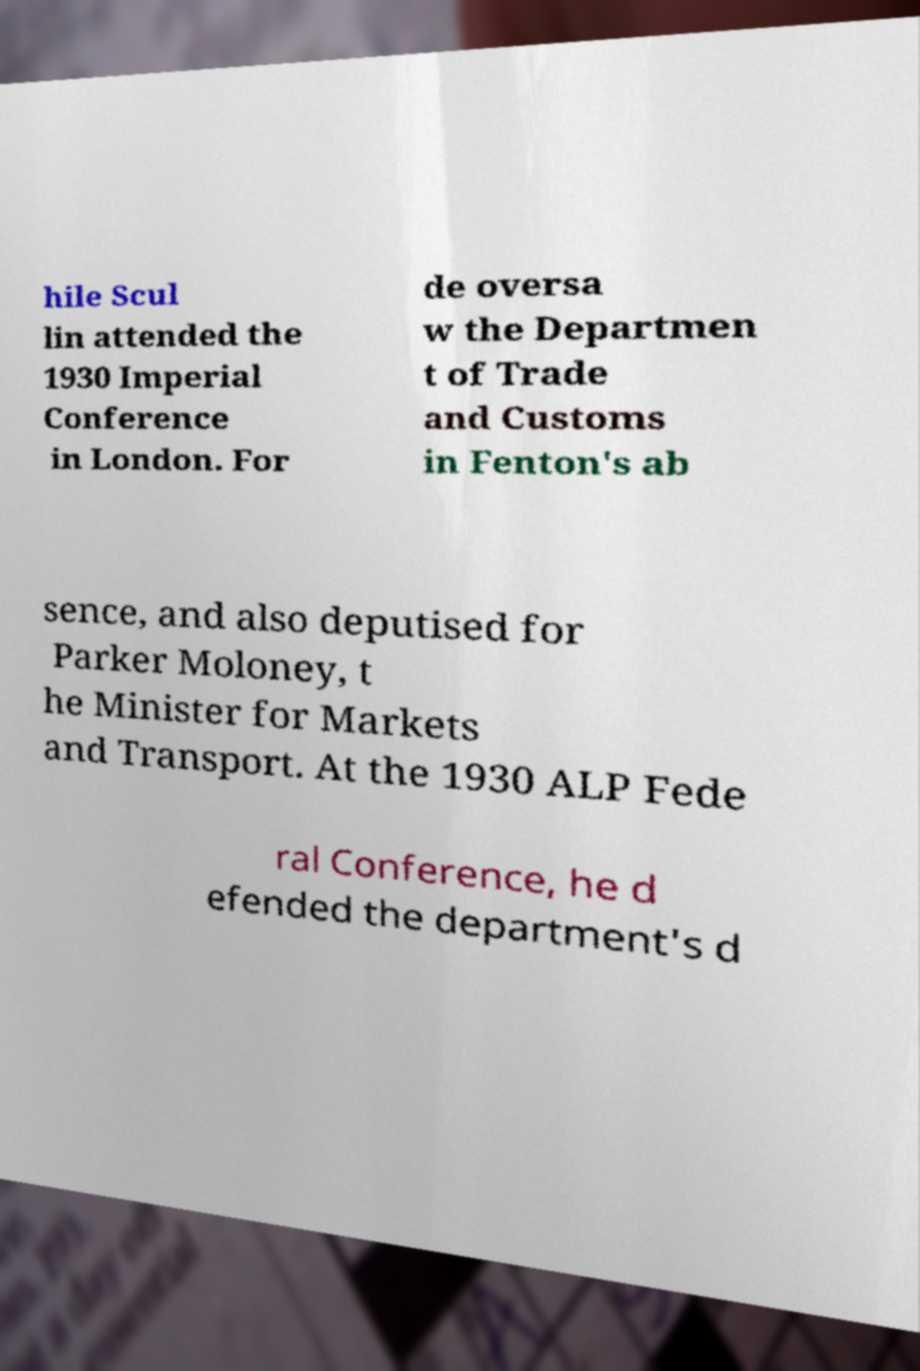Could you assist in decoding the text presented in this image and type it out clearly? hile Scul lin attended the 1930 Imperial Conference in London. For de oversa w the Departmen t of Trade and Customs in Fenton's ab sence, and also deputised for Parker Moloney, t he Minister for Markets and Transport. At the 1930 ALP Fede ral Conference, he d efended the department's d 